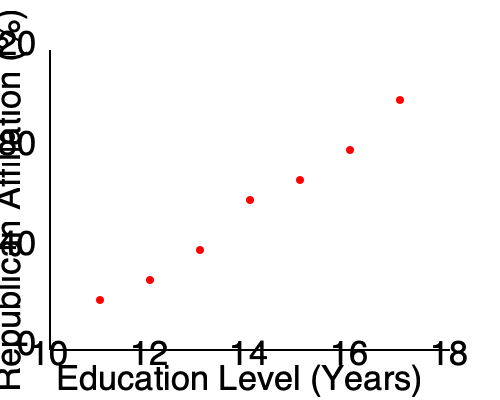Based on the scatter plot showing the relationship between education levels and Republican Party affiliation in Texas, what type of correlation is observed, and how might this information be relevant to political campaigning strategies in Bexar County? To answer this question, let's analyze the scatter plot step-by-step:

1. Observe the overall trend: As we move from left to right (increasing education levels), the data points tend to move downward (decreasing Republican affiliation).

2. Identify the correlation type: This pattern indicates a negative correlation between education levels and Republican Party affiliation.

3. Strength of correlation: The points form a fairly consistent downward trend, suggesting a moderately strong negative correlation.

4. Linearity: The relationship appears to be approximately linear, as the points roughly follow a straight line.

5. Relevance to Bexar County:
   a) Bexar County contains San Antonio, a major urban area with diverse educational institutions.
   b) The county's demographics likely include a wide range of education levels.
   c) This data suggests that higher education levels correlate with lower Republican affiliation.

6. Implications for political campaigning:
   a) Republican campaigns might focus on issues that appeal to voters with lower education levels.
   b) Democratic campaigns could target highly educated areas.
   c) Both parties might adjust their messaging based on the education levels of different neighborhoods.

7. Limitations:
   a) Correlation does not imply causation.
   b) Other factors (e.g., income, age) may also influence party affiliation.
   c) This data is for Texas overall and may not perfectly reflect Bexar County specifically.

In conclusion, the scatter plot shows a moderately strong negative correlation between education levels and Republican Party affiliation in Texas. This information could be used to tailor political campaigning strategies in Bexar County, but should be considered alongside other demographic factors and local data.
Answer: Moderately strong negative correlation; campaigns can target based on education levels. 